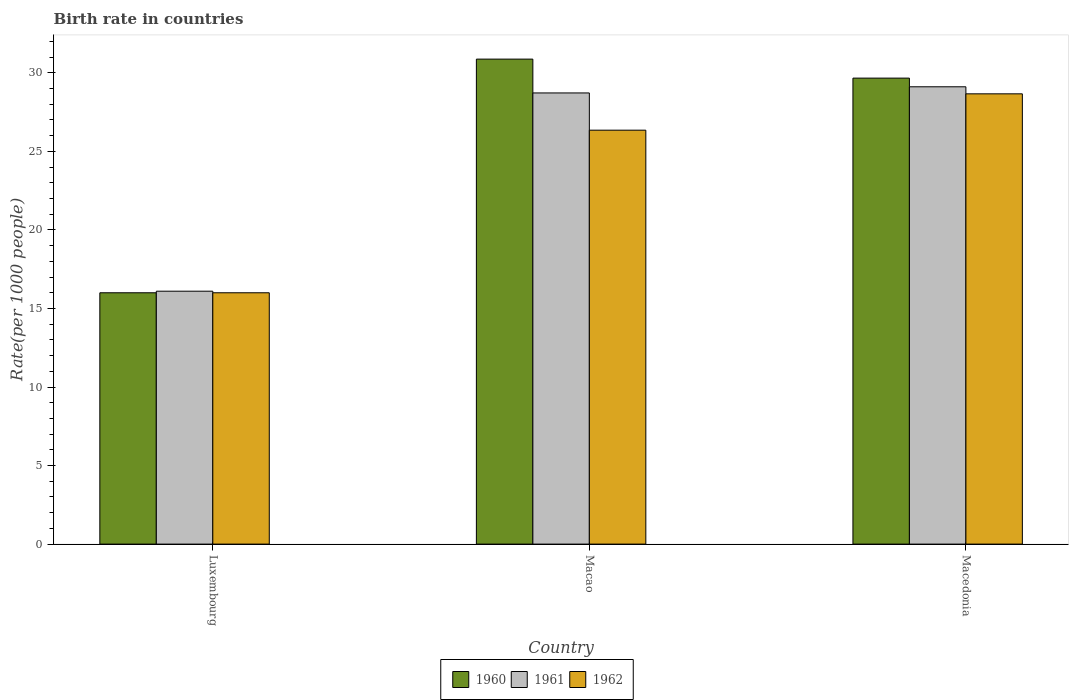How many different coloured bars are there?
Make the answer very short. 3. Are the number of bars per tick equal to the number of legend labels?
Ensure brevity in your answer.  Yes. How many bars are there on the 3rd tick from the left?
Make the answer very short. 3. What is the label of the 2nd group of bars from the left?
Make the answer very short. Macao. Across all countries, what is the maximum birth rate in 1960?
Make the answer very short. 30.87. In which country was the birth rate in 1961 maximum?
Provide a short and direct response. Macedonia. In which country was the birth rate in 1961 minimum?
Offer a very short reply. Luxembourg. What is the total birth rate in 1960 in the graph?
Your answer should be very brief. 76.54. What is the difference between the birth rate in 1961 in Luxembourg and that in Macao?
Your response must be concise. -12.62. What is the difference between the birth rate in 1962 in Macao and the birth rate in 1960 in Macedonia?
Make the answer very short. -3.31. What is the average birth rate in 1962 per country?
Provide a succinct answer. 23.67. What is the difference between the birth rate of/in 1962 and birth rate of/in 1960 in Macedonia?
Ensure brevity in your answer.  -1. In how many countries, is the birth rate in 1962 greater than 29?
Offer a terse response. 0. What is the ratio of the birth rate in 1962 in Macao to that in Macedonia?
Give a very brief answer. 0.92. Is the difference between the birth rate in 1962 in Luxembourg and Macedonia greater than the difference between the birth rate in 1960 in Luxembourg and Macedonia?
Give a very brief answer. Yes. What is the difference between the highest and the second highest birth rate in 1962?
Give a very brief answer. -10.35. What is the difference between the highest and the lowest birth rate in 1961?
Make the answer very short. 13.01. How many bars are there?
Your response must be concise. 9. Are all the bars in the graph horizontal?
Your answer should be very brief. No. How many countries are there in the graph?
Your answer should be very brief. 3. Are the values on the major ticks of Y-axis written in scientific E-notation?
Make the answer very short. No. Does the graph contain any zero values?
Give a very brief answer. No. Where does the legend appear in the graph?
Give a very brief answer. Bottom center. How are the legend labels stacked?
Your response must be concise. Horizontal. What is the title of the graph?
Give a very brief answer. Birth rate in countries. Does "2015" appear as one of the legend labels in the graph?
Provide a succinct answer. No. What is the label or title of the X-axis?
Your answer should be very brief. Country. What is the label or title of the Y-axis?
Give a very brief answer. Rate(per 1000 people). What is the Rate(per 1000 people) of 1960 in Luxembourg?
Your answer should be compact. 16. What is the Rate(per 1000 people) in 1961 in Luxembourg?
Offer a very short reply. 16.1. What is the Rate(per 1000 people) in 1962 in Luxembourg?
Your response must be concise. 16. What is the Rate(per 1000 people) in 1960 in Macao?
Give a very brief answer. 30.87. What is the Rate(per 1000 people) in 1961 in Macao?
Your response must be concise. 28.72. What is the Rate(per 1000 people) of 1962 in Macao?
Give a very brief answer. 26.35. What is the Rate(per 1000 people) of 1960 in Macedonia?
Your answer should be compact. 29.66. What is the Rate(per 1000 people) in 1961 in Macedonia?
Provide a short and direct response. 29.11. What is the Rate(per 1000 people) of 1962 in Macedonia?
Make the answer very short. 28.66. Across all countries, what is the maximum Rate(per 1000 people) in 1960?
Ensure brevity in your answer.  30.87. Across all countries, what is the maximum Rate(per 1000 people) in 1961?
Give a very brief answer. 29.11. Across all countries, what is the maximum Rate(per 1000 people) of 1962?
Keep it short and to the point. 28.66. Across all countries, what is the minimum Rate(per 1000 people) of 1962?
Your answer should be compact. 16. What is the total Rate(per 1000 people) in 1960 in the graph?
Keep it short and to the point. 76.54. What is the total Rate(per 1000 people) of 1961 in the graph?
Your answer should be very brief. 73.93. What is the total Rate(per 1000 people) of 1962 in the graph?
Give a very brief answer. 71.02. What is the difference between the Rate(per 1000 people) in 1960 in Luxembourg and that in Macao?
Provide a succinct answer. -14.87. What is the difference between the Rate(per 1000 people) in 1961 in Luxembourg and that in Macao?
Your answer should be very brief. -12.62. What is the difference between the Rate(per 1000 people) of 1962 in Luxembourg and that in Macao?
Ensure brevity in your answer.  -10.35. What is the difference between the Rate(per 1000 people) in 1960 in Luxembourg and that in Macedonia?
Ensure brevity in your answer.  -13.66. What is the difference between the Rate(per 1000 people) in 1961 in Luxembourg and that in Macedonia?
Your answer should be compact. -13.01. What is the difference between the Rate(per 1000 people) of 1962 in Luxembourg and that in Macedonia?
Keep it short and to the point. -12.66. What is the difference between the Rate(per 1000 people) of 1960 in Macao and that in Macedonia?
Provide a succinct answer. 1.21. What is the difference between the Rate(per 1000 people) in 1961 in Macao and that in Macedonia?
Make the answer very short. -0.39. What is the difference between the Rate(per 1000 people) in 1962 in Macao and that in Macedonia?
Provide a short and direct response. -2.31. What is the difference between the Rate(per 1000 people) in 1960 in Luxembourg and the Rate(per 1000 people) in 1961 in Macao?
Your response must be concise. -12.72. What is the difference between the Rate(per 1000 people) in 1960 in Luxembourg and the Rate(per 1000 people) in 1962 in Macao?
Provide a short and direct response. -10.35. What is the difference between the Rate(per 1000 people) in 1961 in Luxembourg and the Rate(per 1000 people) in 1962 in Macao?
Provide a succinct answer. -10.25. What is the difference between the Rate(per 1000 people) in 1960 in Luxembourg and the Rate(per 1000 people) in 1961 in Macedonia?
Your answer should be very brief. -13.11. What is the difference between the Rate(per 1000 people) of 1960 in Luxembourg and the Rate(per 1000 people) of 1962 in Macedonia?
Your response must be concise. -12.66. What is the difference between the Rate(per 1000 people) in 1961 in Luxembourg and the Rate(per 1000 people) in 1962 in Macedonia?
Give a very brief answer. -12.56. What is the difference between the Rate(per 1000 people) of 1960 in Macao and the Rate(per 1000 people) of 1961 in Macedonia?
Make the answer very short. 1.76. What is the difference between the Rate(per 1000 people) in 1960 in Macao and the Rate(per 1000 people) in 1962 in Macedonia?
Make the answer very short. 2.21. What is the difference between the Rate(per 1000 people) in 1961 in Macao and the Rate(per 1000 people) in 1962 in Macedonia?
Keep it short and to the point. 0.06. What is the average Rate(per 1000 people) of 1960 per country?
Make the answer very short. 25.51. What is the average Rate(per 1000 people) of 1961 per country?
Your answer should be compact. 24.64. What is the average Rate(per 1000 people) in 1962 per country?
Your response must be concise. 23.67. What is the difference between the Rate(per 1000 people) in 1960 and Rate(per 1000 people) in 1961 in Macao?
Provide a short and direct response. 2.15. What is the difference between the Rate(per 1000 people) of 1960 and Rate(per 1000 people) of 1962 in Macao?
Keep it short and to the point. 4.52. What is the difference between the Rate(per 1000 people) in 1961 and Rate(per 1000 people) in 1962 in Macao?
Provide a short and direct response. 2.37. What is the difference between the Rate(per 1000 people) of 1960 and Rate(per 1000 people) of 1961 in Macedonia?
Your response must be concise. 0.55. What is the difference between the Rate(per 1000 people) in 1960 and Rate(per 1000 people) in 1962 in Macedonia?
Your answer should be very brief. 1. What is the difference between the Rate(per 1000 people) in 1961 and Rate(per 1000 people) in 1962 in Macedonia?
Make the answer very short. 0.45. What is the ratio of the Rate(per 1000 people) in 1960 in Luxembourg to that in Macao?
Offer a terse response. 0.52. What is the ratio of the Rate(per 1000 people) in 1961 in Luxembourg to that in Macao?
Your answer should be compact. 0.56. What is the ratio of the Rate(per 1000 people) in 1962 in Luxembourg to that in Macao?
Offer a terse response. 0.61. What is the ratio of the Rate(per 1000 people) of 1960 in Luxembourg to that in Macedonia?
Your answer should be very brief. 0.54. What is the ratio of the Rate(per 1000 people) in 1961 in Luxembourg to that in Macedonia?
Keep it short and to the point. 0.55. What is the ratio of the Rate(per 1000 people) of 1962 in Luxembourg to that in Macedonia?
Make the answer very short. 0.56. What is the ratio of the Rate(per 1000 people) of 1960 in Macao to that in Macedonia?
Provide a succinct answer. 1.04. What is the ratio of the Rate(per 1000 people) of 1961 in Macao to that in Macedonia?
Offer a terse response. 0.99. What is the ratio of the Rate(per 1000 people) of 1962 in Macao to that in Macedonia?
Give a very brief answer. 0.92. What is the difference between the highest and the second highest Rate(per 1000 people) in 1960?
Offer a terse response. 1.21. What is the difference between the highest and the second highest Rate(per 1000 people) in 1961?
Keep it short and to the point. 0.39. What is the difference between the highest and the second highest Rate(per 1000 people) in 1962?
Offer a terse response. 2.31. What is the difference between the highest and the lowest Rate(per 1000 people) in 1960?
Provide a short and direct response. 14.87. What is the difference between the highest and the lowest Rate(per 1000 people) of 1961?
Provide a succinct answer. 13.01. What is the difference between the highest and the lowest Rate(per 1000 people) in 1962?
Offer a terse response. 12.66. 